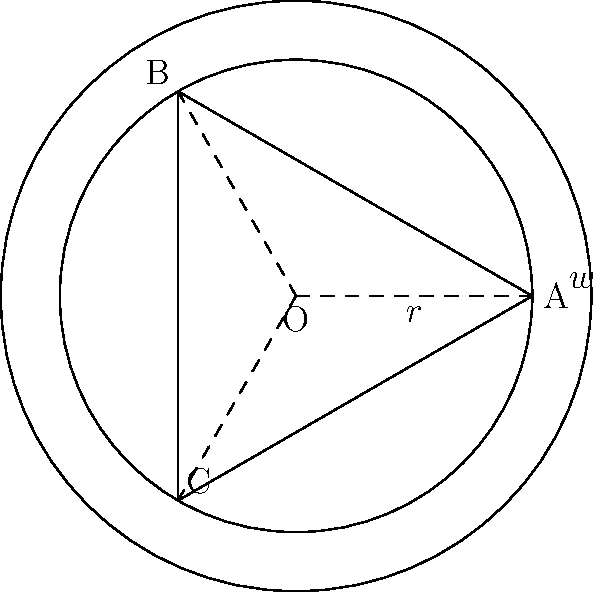As part of the town's infrastructure modernization plan, you're designing a new roundabout to improve traffic flow. The roundabout has an inner circle with radius $r$ and an outer circle with width $w$. If the triangle ABC inscribed in the inner circle has a perimeter of 10.392 units, what is the total area of the roundabout (including both the inner circle and the outer ring)? Let's approach this step-by-step:

1) First, we need to find the radius $r$ of the inner circle.

2) In an equilateral triangle inscribed in a circle, the side length $s$ is related to the radius $r$ by the formula:
   $s = r\sqrt{3}$

3) The perimeter of the triangle is given as 10.392 units. For an equilateral triangle:
   $3s = 10.392$
   $s = 3.464$

4) Using the formula from step 2:
   $3.464 = r\sqrt{3}$
   $r = \frac{3.464}{\sqrt{3}} = 2$

5) Now we know the inner radius $r = 2$ and the width $w = 0.5$ (given in the diagram).

6) The area of the inner circle is:
   $A_1 = \pi r^2 = \pi (2)^2 = 4\pi$

7) The area of the outer circle is:
   $A_2 = \pi (r+w)^2 = \pi (2.5)^2 = 6.25\pi$

8) The area of the roundabout is the difference:
   $A = A_2 - A_1 = 6.25\pi - 4\pi = 2.25\pi$

9) Calculating this:
   $A = 2.25 \pi \approx 7.0686$ square units
Answer: 7.0686 square units 